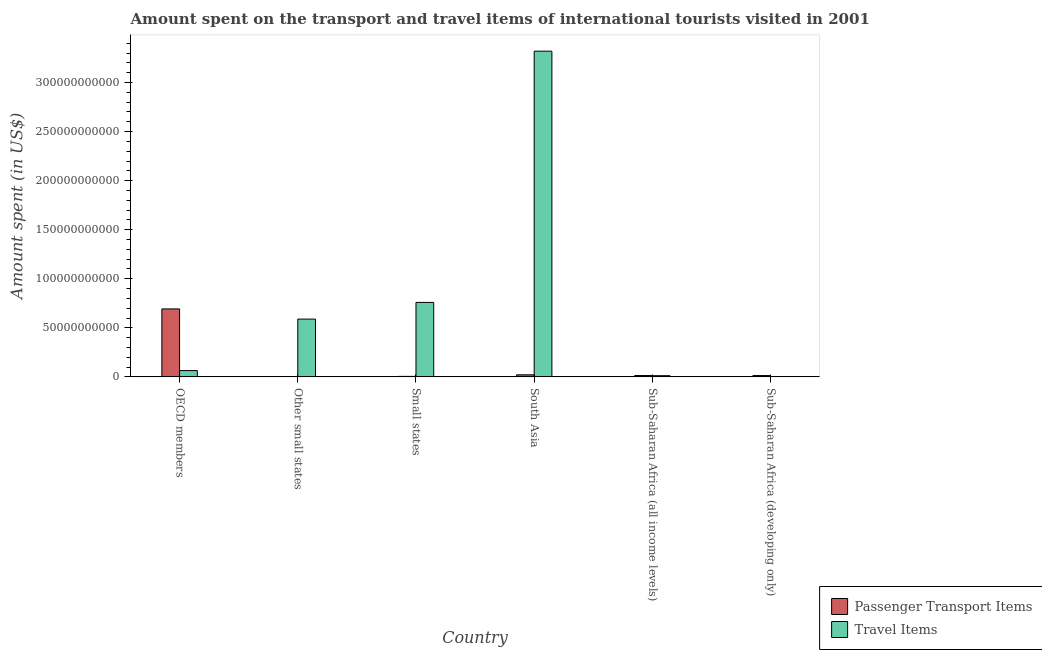Are the number of bars on each tick of the X-axis equal?
Ensure brevity in your answer.  Yes. What is the label of the 2nd group of bars from the left?
Provide a succinct answer. Other small states. What is the amount spent on passenger transport items in Other small states?
Provide a short and direct response. 1.77e+08. Across all countries, what is the maximum amount spent in travel items?
Provide a short and direct response. 3.32e+11. Across all countries, what is the minimum amount spent in travel items?
Your response must be concise. 1.14e+08. In which country was the amount spent in travel items minimum?
Your answer should be very brief. Sub-Saharan Africa (developing only). What is the total amount spent in travel items in the graph?
Keep it short and to the point. 4.75e+11. What is the difference between the amount spent in travel items in Other small states and that in South Asia?
Keep it short and to the point. -2.73e+11. What is the difference between the amount spent on passenger transport items in Sub-Saharan Africa (all income levels) and the amount spent in travel items in Sub-Saharan Africa (developing only)?
Offer a terse response. 1.24e+09. What is the average amount spent in travel items per country?
Provide a succinct answer. 7.91e+1. What is the difference between the amount spent on passenger transport items and amount spent in travel items in South Asia?
Give a very brief answer. -3.30e+11. In how many countries, is the amount spent on passenger transport items greater than 290000000000 US$?
Make the answer very short. 0. What is the ratio of the amount spent on passenger transport items in OECD members to that in Sub-Saharan Africa (all income levels)?
Your response must be concise. 51.21. Is the difference between the amount spent in travel items in OECD members and Small states greater than the difference between the amount spent on passenger transport items in OECD members and Small states?
Your answer should be compact. No. What is the difference between the highest and the second highest amount spent on passenger transport items?
Provide a succinct answer. 6.72e+1. What is the difference between the highest and the lowest amount spent in travel items?
Provide a short and direct response. 3.32e+11. What does the 1st bar from the left in OECD members represents?
Offer a very short reply. Passenger Transport Items. What does the 2nd bar from the right in Small states represents?
Offer a terse response. Passenger Transport Items. How many bars are there?
Give a very brief answer. 12. Are all the bars in the graph horizontal?
Provide a short and direct response. No. How many countries are there in the graph?
Your response must be concise. 6. Are the values on the major ticks of Y-axis written in scientific E-notation?
Your answer should be compact. No. Does the graph contain any zero values?
Give a very brief answer. No. Where does the legend appear in the graph?
Ensure brevity in your answer.  Bottom right. What is the title of the graph?
Offer a very short reply. Amount spent on the transport and travel items of international tourists visited in 2001. Does "Frequency of shipment arrival" appear as one of the legend labels in the graph?
Provide a short and direct response. No. What is the label or title of the Y-axis?
Give a very brief answer. Amount spent (in US$). What is the Amount spent (in US$) in Passenger Transport Items in OECD members?
Your answer should be compact. 6.93e+1. What is the Amount spent (in US$) of Travel Items in OECD members?
Give a very brief answer. 6.42e+09. What is the Amount spent (in US$) of Passenger Transport Items in Other small states?
Your response must be concise. 1.77e+08. What is the Amount spent (in US$) of Travel Items in Other small states?
Make the answer very short. 5.89e+1. What is the Amount spent (in US$) of Passenger Transport Items in Small states?
Provide a succinct answer. 5.04e+08. What is the Amount spent (in US$) of Travel Items in Small states?
Make the answer very short. 7.59e+1. What is the Amount spent (in US$) of Passenger Transport Items in South Asia?
Your answer should be compact. 2.08e+09. What is the Amount spent (in US$) of Travel Items in South Asia?
Offer a terse response. 3.32e+11. What is the Amount spent (in US$) in Passenger Transport Items in Sub-Saharan Africa (all income levels)?
Provide a short and direct response. 1.35e+09. What is the Amount spent (in US$) in Travel Items in Sub-Saharan Africa (all income levels)?
Your answer should be very brief. 1.21e+09. What is the Amount spent (in US$) in Passenger Transport Items in Sub-Saharan Africa (developing only)?
Offer a terse response. 1.32e+09. What is the Amount spent (in US$) in Travel Items in Sub-Saharan Africa (developing only)?
Your answer should be compact. 1.14e+08. Across all countries, what is the maximum Amount spent (in US$) in Passenger Transport Items?
Provide a succinct answer. 6.93e+1. Across all countries, what is the maximum Amount spent (in US$) in Travel Items?
Give a very brief answer. 3.32e+11. Across all countries, what is the minimum Amount spent (in US$) in Passenger Transport Items?
Your answer should be compact. 1.77e+08. Across all countries, what is the minimum Amount spent (in US$) of Travel Items?
Offer a very short reply. 1.14e+08. What is the total Amount spent (in US$) of Passenger Transport Items in the graph?
Provide a succinct answer. 7.47e+1. What is the total Amount spent (in US$) in Travel Items in the graph?
Make the answer very short. 4.75e+11. What is the difference between the Amount spent (in US$) in Passenger Transport Items in OECD members and that in Other small states?
Give a very brief answer. 6.91e+1. What is the difference between the Amount spent (in US$) of Travel Items in OECD members and that in Other small states?
Provide a succinct answer. -5.25e+1. What is the difference between the Amount spent (in US$) of Passenger Transport Items in OECD members and that in Small states?
Offer a terse response. 6.88e+1. What is the difference between the Amount spent (in US$) of Travel Items in OECD members and that in Small states?
Your response must be concise. -6.95e+1. What is the difference between the Amount spent (in US$) in Passenger Transport Items in OECD members and that in South Asia?
Your response must be concise. 6.72e+1. What is the difference between the Amount spent (in US$) in Travel Items in OECD members and that in South Asia?
Your answer should be very brief. -3.26e+11. What is the difference between the Amount spent (in US$) of Passenger Transport Items in OECD members and that in Sub-Saharan Africa (all income levels)?
Your response must be concise. 6.79e+1. What is the difference between the Amount spent (in US$) of Travel Items in OECD members and that in Sub-Saharan Africa (all income levels)?
Offer a terse response. 5.21e+09. What is the difference between the Amount spent (in US$) in Passenger Transport Items in OECD members and that in Sub-Saharan Africa (developing only)?
Your answer should be very brief. 6.79e+1. What is the difference between the Amount spent (in US$) of Travel Items in OECD members and that in Sub-Saharan Africa (developing only)?
Make the answer very short. 6.31e+09. What is the difference between the Amount spent (in US$) in Passenger Transport Items in Other small states and that in Small states?
Provide a succinct answer. -3.27e+08. What is the difference between the Amount spent (in US$) in Travel Items in Other small states and that in Small states?
Ensure brevity in your answer.  -1.70e+1. What is the difference between the Amount spent (in US$) of Passenger Transport Items in Other small states and that in South Asia?
Your response must be concise. -1.91e+09. What is the difference between the Amount spent (in US$) of Travel Items in Other small states and that in South Asia?
Make the answer very short. -2.73e+11. What is the difference between the Amount spent (in US$) of Passenger Transport Items in Other small states and that in Sub-Saharan Africa (all income levels)?
Provide a succinct answer. -1.18e+09. What is the difference between the Amount spent (in US$) in Travel Items in Other small states and that in Sub-Saharan Africa (all income levels)?
Your response must be concise. 5.77e+1. What is the difference between the Amount spent (in US$) in Passenger Transport Items in Other small states and that in Sub-Saharan Africa (developing only)?
Your response must be concise. -1.14e+09. What is the difference between the Amount spent (in US$) of Travel Items in Other small states and that in Sub-Saharan Africa (developing only)?
Give a very brief answer. 5.88e+1. What is the difference between the Amount spent (in US$) of Passenger Transport Items in Small states and that in South Asia?
Provide a short and direct response. -1.58e+09. What is the difference between the Amount spent (in US$) of Travel Items in Small states and that in South Asia?
Offer a terse response. -2.56e+11. What is the difference between the Amount spent (in US$) of Passenger Transport Items in Small states and that in Sub-Saharan Africa (all income levels)?
Make the answer very short. -8.49e+08. What is the difference between the Amount spent (in US$) of Travel Items in Small states and that in Sub-Saharan Africa (all income levels)?
Provide a short and direct response. 7.47e+1. What is the difference between the Amount spent (in US$) in Passenger Transport Items in Small states and that in Sub-Saharan Africa (developing only)?
Give a very brief answer. -8.18e+08. What is the difference between the Amount spent (in US$) in Travel Items in Small states and that in Sub-Saharan Africa (developing only)?
Your answer should be compact. 7.58e+1. What is the difference between the Amount spent (in US$) of Passenger Transport Items in South Asia and that in Sub-Saharan Africa (all income levels)?
Provide a short and direct response. 7.32e+08. What is the difference between the Amount spent (in US$) of Travel Items in South Asia and that in Sub-Saharan Africa (all income levels)?
Your answer should be very brief. 3.31e+11. What is the difference between the Amount spent (in US$) of Passenger Transport Items in South Asia and that in Sub-Saharan Africa (developing only)?
Provide a short and direct response. 7.62e+08. What is the difference between the Amount spent (in US$) of Travel Items in South Asia and that in Sub-Saharan Africa (developing only)?
Offer a very short reply. 3.32e+11. What is the difference between the Amount spent (in US$) in Passenger Transport Items in Sub-Saharan Africa (all income levels) and that in Sub-Saharan Africa (developing only)?
Your answer should be compact. 3.04e+07. What is the difference between the Amount spent (in US$) in Travel Items in Sub-Saharan Africa (all income levels) and that in Sub-Saharan Africa (developing only)?
Give a very brief answer. 1.10e+09. What is the difference between the Amount spent (in US$) of Passenger Transport Items in OECD members and the Amount spent (in US$) of Travel Items in Other small states?
Ensure brevity in your answer.  1.04e+1. What is the difference between the Amount spent (in US$) of Passenger Transport Items in OECD members and the Amount spent (in US$) of Travel Items in Small states?
Your answer should be compact. -6.63e+09. What is the difference between the Amount spent (in US$) of Passenger Transport Items in OECD members and the Amount spent (in US$) of Travel Items in South Asia?
Your answer should be very brief. -2.63e+11. What is the difference between the Amount spent (in US$) of Passenger Transport Items in OECD members and the Amount spent (in US$) of Travel Items in Sub-Saharan Africa (all income levels)?
Ensure brevity in your answer.  6.81e+1. What is the difference between the Amount spent (in US$) in Passenger Transport Items in OECD members and the Amount spent (in US$) in Travel Items in Sub-Saharan Africa (developing only)?
Ensure brevity in your answer.  6.92e+1. What is the difference between the Amount spent (in US$) of Passenger Transport Items in Other small states and the Amount spent (in US$) of Travel Items in Small states?
Your answer should be compact. -7.57e+1. What is the difference between the Amount spent (in US$) of Passenger Transport Items in Other small states and the Amount spent (in US$) of Travel Items in South Asia?
Keep it short and to the point. -3.32e+11. What is the difference between the Amount spent (in US$) of Passenger Transport Items in Other small states and the Amount spent (in US$) of Travel Items in Sub-Saharan Africa (all income levels)?
Offer a terse response. -1.04e+09. What is the difference between the Amount spent (in US$) of Passenger Transport Items in Other small states and the Amount spent (in US$) of Travel Items in Sub-Saharan Africa (developing only)?
Your answer should be compact. 6.32e+07. What is the difference between the Amount spent (in US$) in Passenger Transport Items in Small states and the Amount spent (in US$) in Travel Items in South Asia?
Ensure brevity in your answer.  -3.32e+11. What is the difference between the Amount spent (in US$) of Passenger Transport Items in Small states and the Amount spent (in US$) of Travel Items in Sub-Saharan Africa (all income levels)?
Provide a succinct answer. -7.09e+08. What is the difference between the Amount spent (in US$) in Passenger Transport Items in Small states and the Amount spent (in US$) in Travel Items in Sub-Saharan Africa (developing only)?
Make the answer very short. 3.90e+08. What is the difference between the Amount spent (in US$) in Passenger Transport Items in South Asia and the Amount spent (in US$) in Travel Items in Sub-Saharan Africa (all income levels)?
Provide a succinct answer. 8.71e+08. What is the difference between the Amount spent (in US$) of Passenger Transport Items in South Asia and the Amount spent (in US$) of Travel Items in Sub-Saharan Africa (developing only)?
Offer a terse response. 1.97e+09. What is the difference between the Amount spent (in US$) of Passenger Transport Items in Sub-Saharan Africa (all income levels) and the Amount spent (in US$) of Travel Items in Sub-Saharan Africa (developing only)?
Ensure brevity in your answer.  1.24e+09. What is the average Amount spent (in US$) in Passenger Transport Items per country?
Provide a short and direct response. 1.25e+1. What is the average Amount spent (in US$) of Travel Items per country?
Your answer should be very brief. 7.91e+1. What is the difference between the Amount spent (in US$) in Passenger Transport Items and Amount spent (in US$) in Travel Items in OECD members?
Give a very brief answer. 6.28e+1. What is the difference between the Amount spent (in US$) of Passenger Transport Items and Amount spent (in US$) of Travel Items in Other small states?
Make the answer very short. -5.87e+1. What is the difference between the Amount spent (in US$) of Passenger Transport Items and Amount spent (in US$) of Travel Items in Small states?
Offer a very short reply. -7.54e+1. What is the difference between the Amount spent (in US$) of Passenger Transport Items and Amount spent (in US$) of Travel Items in South Asia?
Provide a succinct answer. -3.30e+11. What is the difference between the Amount spent (in US$) of Passenger Transport Items and Amount spent (in US$) of Travel Items in Sub-Saharan Africa (all income levels)?
Give a very brief answer. 1.39e+08. What is the difference between the Amount spent (in US$) in Passenger Transport Items and Amount spent (in US$) in Travel Items in Sub-Saharan Africa (developing only)?
Your answer should be compact. 1.21e+09. What is the ratio of the Amount spent (in US$) in Passenger Transport Items in OECD members to that in Other small states?
Give a very brief answer. 390.71. What is the ratio of the Amount spent (in US$) of Travel Items in OECD members to that in Other small states?
Provide a succinct answer. 0.11. What is the ratio of the Amount spent (in US$) of Passenger Transport Items in OECD members to that in Small states?
Offer a very short reply. 137.48. What is the ratio of the Amount spent (in US$) of Travel Items in OECD members to that in Small states?
Keep it short and to the point. 0.08. What is the ratio of the Amount spent (in US$) in Passenger Transport Items in OECD members to that in South Asia?
Your answer should be compact. 33.23. What is the ratio of the Amount spent (in US$) of Travel Items in OECD members to that in South Asia?
Your response must be concise. 0.02. What is the ratio of the Amount spent (in US$) of Passenger Transport Items in OECD members to that in Sub-Saharan Africa (all income levels)?
Your answer should be very brief. 51.21. What is the ratio of the Amount spent (in US$) of Travel Items in OECD members to that in Sub-Saharan Africa (all income levels)?
Provide a succinct answer. 5.3. What is the ratio of the Amount spent (in US$) of Passenger Transport Items in OECD members to that in Sub-Saharan Africa (developing only)?
Offer a very short reply. 52.39. What is the ratio of the Amount spent (in US$) in Travel Items in OECD members to that in Sub-Saharan Africa (developing only)?
Make the answer very short. 56.33. What is the ratio of the Amount spent (in US$) in Passenger Transport Items in Other small states to that in Small states?
Your answer should be compact. 0.35. What is the ratio of the Amount spent (in US$) of Travel Items in Other small states to that in Small states?
Make the answer very short. 0.78. What is the ratio of the Amount spent (in US$) of Passenger Transport Items in Other small states to that in South Asia?
Your answer should be very brief. 0.09. What is the ratio of the Amount spent (in US$) in Travel Items in Other small states to that in South Asia?
Make the answer very short. 0.18. What is the ratio of the Amount spent (in US$) of Passenger Transport Items in Other small states to that in Sub-Saharan Africa (all income levels)?
Your answer should be very brief. 0.13. What is the ratio of the Amount spent (in US$) of Travel Items in Other small states to that in Sub-Saharan Africa (all income levels)?
Provide a short and direct response. 48.55. What is the ratio of the Amount spent (in US$) of Passenger Transport Items in Other small states to that in Sub-Saharan Africa (developing only)?
Your answer should be compact. 0.13. What is the ratio of the Amount spent (in US$) of Travel Items in Other small states to that in Sub-Saharan Africa (developing only)?
Your answer should be compact. 516.44. What is the ratio of the Amount spent (in US$) in Passenger Transport Items in Small states to that in South Asia?
Your response must be concise. 0.24. What is the ratio of the Amount spent (in US$) in Travel Items in Small states to that in South Asia?
Provide a succinct answer. 0.23. What is the ratio of the Amount spent (in US$) in Passenger Transport Items in Small states to that in Sub-Saharan Africa (all income levels)?
Ensure brevity in your answer.  0.37. What is the ratio of the Amount spent (in US$) of Travel Items in Small states to that in Sub-Saharan Africa (all income levels)?
Your answer should be very brief. 62.56. What is the ratio of the Amount spent (in US$) in Passenger Transport Items in Small states to that in Sub-Saharan Africa (developing only)?
Ensure brevity in your answer.  0.38. What is the ratio of the Amount spent (in US$) of Travel Items in Small states to that in Sub-Saharan Africa (developing only)?
Give a very brief answer. 665.53. What is the ratio of the Amount spent (in US$) in Passenger Transport Items in South Asia to that in Sub-Saharan Africa (all income levels)?
Keep it short and to the point. 1.54. What is the ratio of the Amount spent (in US$) in Travel Items in South Asia to that in Sub-Saharan Africa (all income levels)?
Offer a terse response. 273.68. What is the ratio of the Amount spent (in US$) in Passenger Transport Items in South Asia to that in Sub-Saharan Africa (developing only)?
Offer a terse response. 1.58. What is the ratio of the Amount spent (in US$) in Travel Items in South Asia to that in Sub-Saharan Africa (developing only)?
Make the answer very short. 2911.34. What is the ratio of the Amount spent (in US$) of Travel Items in Sub-Saharan Africa (all income levels) to that in Sub-Saharan Africa (developing only)?
Provide a succinct answer. 10.64. What is the difference between the highest and the second highest Amount spent (in US$) of Passenger Transport Items?
Your answer should be very brief. 6.72e+1. What is the difference between the highest and the second highest Amount spent (in US$) in Travel Items?
Make the answer very short. 2.56e+11. What is the difference between the highest and the lowest Amount spent (in US$) in Passenger Transport Items?
Provide a succinct answer. 6.91e+1. What is the difference between the highest and the lowest Amount spent (in US$) in Travel Items?
Your response must be concise. 3.32e+11. 